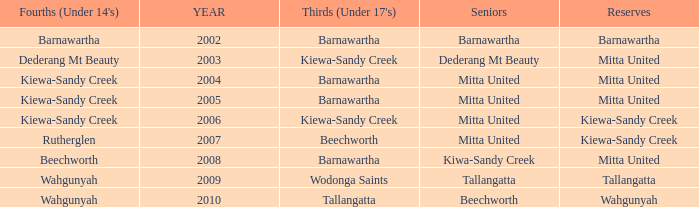Which Seniors have YEAR before 2006, and Fourths (Under 14's) of kiewa-sandy creek? Mitta United, Mitta United. 